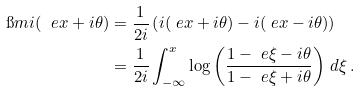Convert formula to latex. <formula><loc_0><loc_0><loc_500><loc_500>\i m \L i ( \ e { x + i \theta } ) & = \frac { 1 } { 2 i } \left ( \L i ( \ e { x + i \theta } ) - \L i ( \ e { x - i \theta } ) \right ) \\ & = \frac { 1 } { 2 i } \int _ { - \infty } ^ { x } \log \left ( \frac { 1 - \ e { \xi - i \theta } } { 1 - \ e { \xi + i \theta } } \right ) \, d \xi \, .</formula> 